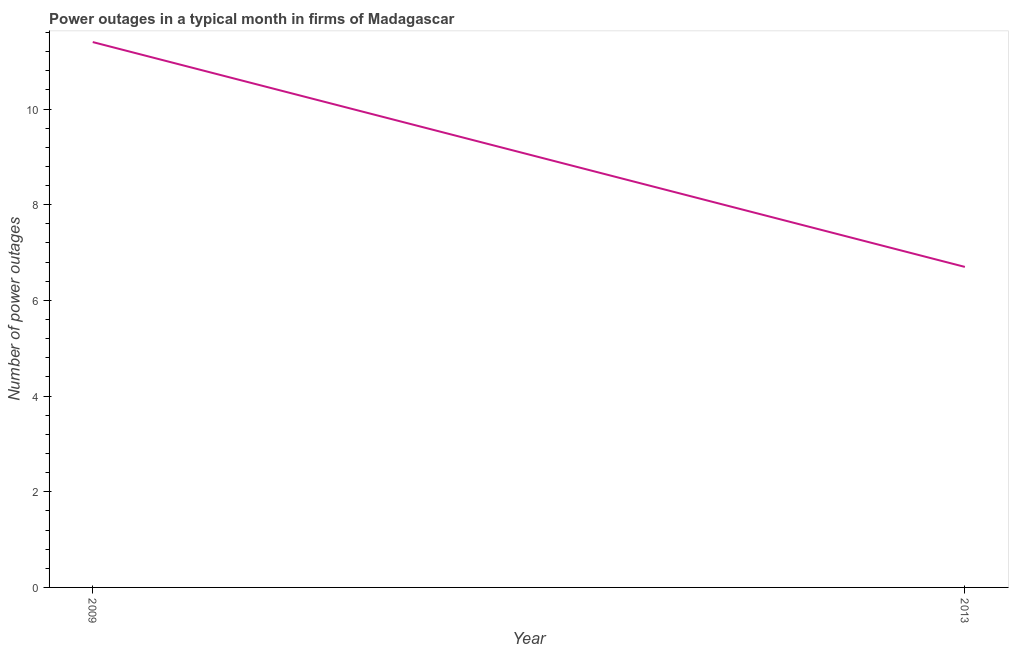What is the number of power outages in 2009?
Offer a terse response. 11.4. In which year was the number of power outages maximum?
Keep it short and to the point. 2009. In which year was the number of power outages minimum?
Offer a very short reply. 2013. What is the difference between the number of power outages in 2009 and 2013?
Your response must be concise. 4.7. What is the average number of power outages per year?
Ensure brevity in your answer.  9.05. What is the median number of power outages?
Give a very brief answer. 9.05. In how many years, is the number of power outages greater than 0.8 ?
Provide a short and direct response. 2. What is the ratio of the number of power outages in 2009 to that in 2013?
Give a very brief answer. 1.7. In how many years, is the number of power outages greater than the average number of power outages taken over all years?
Ensure brevity in your answer.  1. Does the number of power outages monotonically increase over the years?
Keep it short and to the point. No. What is the difference between two consecutive major ticks on the Y-axis?
Your answer should be compact. 2. Does the graph contain any zero values?
Your answer should be very brief. No. What is the title of the graph?
Provide a short and direct response. Power outages in a typical month in firms of Madagascar. What is the label or title of the Y-axis?
Offer a very short reply. Number of power outages. What is the Number of power outages in 2013?
Keep it short and to the point. 6.7. What is the difference between the Number of power outages in 2009 and 2013?
Your response must be concise. 4.7. What is the ratio of the Number of power outages in 2009 to that in 2013?
Your answer should be very brief. 1.7. 